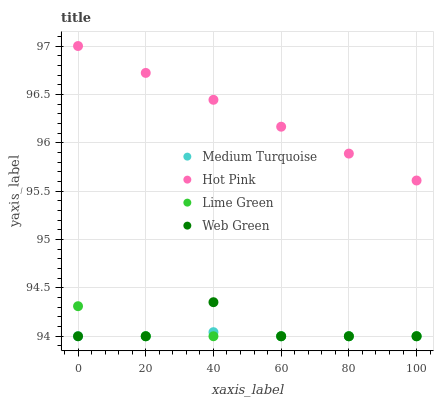Does Medium Turquoise have the minimum area under the curve?
Answer yes or no. Yes. Does Hot Pink have the maximum area under the curve?
Answer yes or no. Yes. Does Lime Green have the minimum area under the curve?
Answer yes or no. No. Does Lime Green have the maximum area under the curve?
Answer yes or no. No. Is Hot Pink the smoothest?
Answer yes or no. Yes. Is Web Green the roughest?
Answer yes or no. Yes. Is Lime Green the smoothest?
Answer yes or no. No. Is Lime Green the roughest?
Answer yes or no. No. Does Lime Green have the lowest value?
Answer yes or no. Yes. Does Hot Pink have the highest value?
Answer yes or no. Yes. Does Lime Green have the highest value?
Answer yes or no. No. Is Lime Green less than Hot Pink?
Answer yes or no. Yes. Is Hot Pink greater than Web Green?
Answer yes or no. Yes. Does Web Green intersect Medium Turquoise?
Answer yes or no. Yes. Is Web Green less than Medium Turquoise?
Answer yes or no. No. Is Web Green greater than Medium Turquoise?
Answer yes or no. No. Does Lime Green intersect Hot Pink?
Answer yes or no. No. 